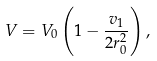Convert formula to latex. <formula><loc_0><loc_0><loc_500><loc_500>V = V _ { 0 } \left ( 1 - { \frac { v _ { 1 } } { 2 r _ { 0 } ^ { 2 } } } \right ) ,</formula> 